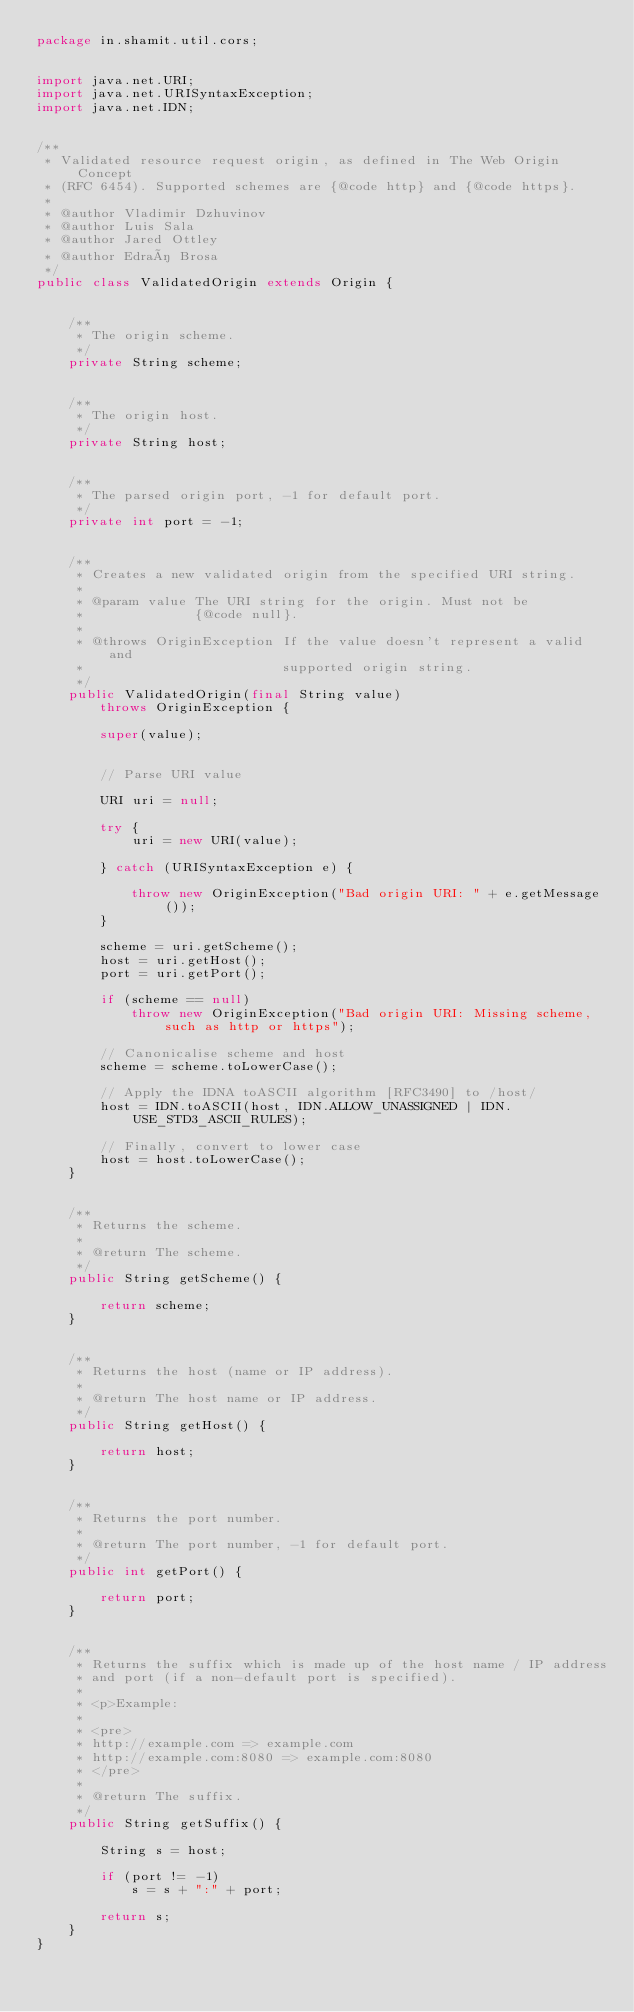Convert code to text. <code><loc_0><loc_0><loc_500><loc_500><_Java_>package in.shamit.util.cors;


import java.net.URI;
import java.net.URISyntaxException;
import java.net.IDN;


/**
 * Validated resource request origin, as defined in The Web Origin Concept 
 * (RFC 6454). Supported schemes are {@code http} and {@code https}.
 *
 * @author Vladimir Dzhuvinov
 * @author Luis Sala
 * @author Jared Ottley
 * @author Edraí Brosa
 */
public class ValidatedOrigin extends Origin {
	
	
	/**
	 * The origin scheme.
	 */
	private String scheme;
	
	
	/**
	 * The origin host.
	 */
	private String host;
	
	
	/**
	 * The parsed origin port, -1 for default port.
	 */
	private int port = -1;

	
	/**
	 * Creates a new validated origin from the specified URI string.
	 *
	 * @param value The URI string for the origin. Must not be 
	 *              {@code null}.
	 *
	 * @throws OriginException If the value doesn't represent a valid and
	 *                         supported origin string.
	 */
	public ValidatedOrigin(final String value)
		throws OriginException {
	
		super(value);
		
		
		// Parse URI value
	
		URI uri = null;
	
		try {
			uri = new URI(value);
			
		} catch (URISyntaxException e) {
		
			throw new OriginException("Bad origin URI: " + e.getMessage());
		}
		
		scheme = uri.getScheme();
		host = uri.getHost();
		port = uri.getPort();
		
		if (scheme == null)
			throw new OriginException("Bad origin URI: Missing scheme, such as http or https");
		
		// Canonicalise scheme and host
		scheme = scheme.toLowerCase();
		
		// Apply the IDNA toASCII algorithm [RFC3490] to /host/
		host = IDN.toASCII(host, IDN.ALLOW_UNASSIGNED | IDN.USE_STD3_ASCII_RULES);
	
		// Finally, convert to lower case
		host = host.toLowerCase();
	}
	
	
	/**
	 * Returns the scheme.
	 *
	 * @return The scheme.
	 */
	public String getScheme() {

		return scheme;
	}
	
	
	/**
	 * Returns the host (name or IP address).
	 *
	 * @return The host name or IP address.
	 */
	public String getHost() {
	
		return host;
	}
	
	
	/**
	 * Returns the port number.
	 *
	 * @return The port number, -1 for default port.
	 */
	public int getPort() {
	
		return port;
	}
	
	
	/**
	 * Returns the suffix which is made up of the host name / IP address 
	 * and port (if a non-default port is specified).
	 *
	 * <p>Example:
	 *
	 * <pre>
	 * http://example.com => example.com
	 * http://example.com:8080 => example.com:8080
	 * </pre>
	 *
	 * @return The suffix.
	 */
	public String getSuffix() {
		
		String s = host;
		
		if (port != -1)
			s = s + ":" + port;
		
		return s;
	}
}
</code> 